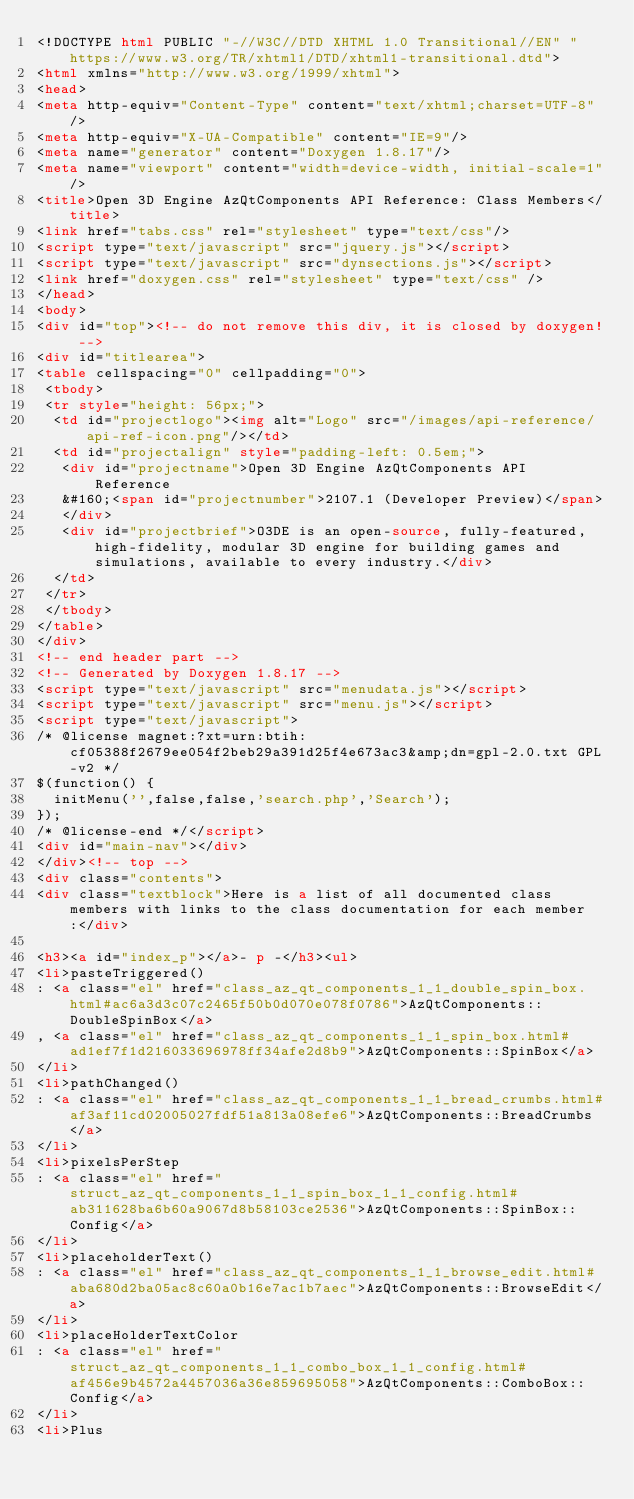Convert code to text. <code><loc_0><loc_0><loc_500><loc_500><_HTML_><!DOCTYPE html PUBLIC "-//W3C//DTD XHTML 1.0 Transitional//EN" "https://www.w3.org/TR/xhtml1/DTD/xhtml1-transitional.dtd">
<html xmlns="http://www.w3.org/1999/xhtml">
<head>
<meta http-equiv="Content-Type" content="text/xhtml;charset=UTF-8"/>
<meta http-equiv="X-UA-Compatible" content="IE=9"/>
<meta name="generator" content="Doxygen 1.8.17"/>
<meta name="viewport" content="width=device-width, initial-scale=1"/>
<title>Open 3D Engine AzQtComponents API Reference: Class Members</title>
<link href="tabs.css" rel="stylesheet" type="text/css"/>
<script type="text/javascript" src="jquery.js"></script>
<script type="text/javascript" src="dynsections.js"></script>
<link href="doxygen.css" rel="stylesheet" type="text/css" />
</head>
<body>
<div id="top"><!-- do not remove this div, it is closed by doxygen! -->
<div id="titlearea">
<table cellspacing="0" cellpadding="0">
 <tbody>
 <tr style="height: 56px;">
  <td id="projectlogo"><img alt="Logo" src="/images/api-reference/api-ref-icon.png"/></td>
  <td id="projectalign" style="padding-left: 0.5em;">
   <div id="projectname">Open 3D Engine AzQtComponents API Reference
   &#160;<span id="projectnumber">2107.1 (Developer Preview)</span>
   </div>
   <div id="projectbrief">O3DE is an open-source, fully-featured, high-fidelity, modular 3D engine for building games and simulations, available to every industry.</div>
  </td>
 </tr>
 </tbody>
</table>
</div>
<!-- end header part -->
<!-- Generated by Doxygen 1.8.17 -->
<script type="text/javascript" src="menudata.js"></script>
<script type="text/javascript" src="menu.js"></script>
<script type="text/javascript">
/* @license magnet:?xt=urn:btih:cf05388f2679ee054f2beb29a391d25f4e673ac3&amp;dn=gpl-2.0.txt GPL-v2 */
$(function() {
  initMenu('',false,false,'search.php','Search');
});
/* @license-end */</script>
<div id="main-nav"></div>
</div><!-- top -->
<div class="contents">
<div class="textblock">Here is a list of all documented class members with links to the class documentation for each member:</div>

<h3><a id="index_p"></a>- p -</h3><ul>
<li>pasteTriggered()
: <a class="el" href="class_az_qt_components_1_1_double_spin_box.html#ac6a3d3c07c2465f50b0d070e078f0786">AzQtComponents::DoubleSpinBox</a>
, <a class="el" href="class_az_qt_components_1_1_spin_box.html#ad1ef7f1d216033696978ff34afe2d8b9">AzQtComponents::SpinBox</a>
</li>
<li>pathChanged()
: <a class="el" href="class_az_qt_components_1_1_bread_crumbs.html#af3af11cd02005027fdf51a813a08efe6">AzQtComponents::BreadCrumbs</a>
</li>
<li>pixelsPerStep
: <a class="el" href="struct_az_qt_components_1_1_spin_box_1_1_config.html#ab311628ba6b60a9067d8b58103ce2536">AzQtComponents::SpinBox::Config</a>
</li>
<li>placeholderText()
: <a class="el" href="class_az_qt_components_1_1_browse_edit.html#aba680d2ba05ac8c60a0b16e7ac1b7aec">AzQtComponents::BrowseEdit</a>
</li>
<li>placeHolderTextColor
: <a class="el" href="struct_az_qt_components_1_1_combo_box_1_1_config.html#af456e9b4572a4457036a36e859695058">AzQtComponents::ComboBox::Config</a>
</li>
<li>Plus</code> 